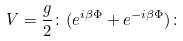Convert formula to latex. <formula><loc_0><loc_0><loc_500><loc_500>V = \frac { g } { 2 } \colon ( e ^ { i \beta \Phi } + e ^ { - i \beta \Phi } ) \colon</formula> 